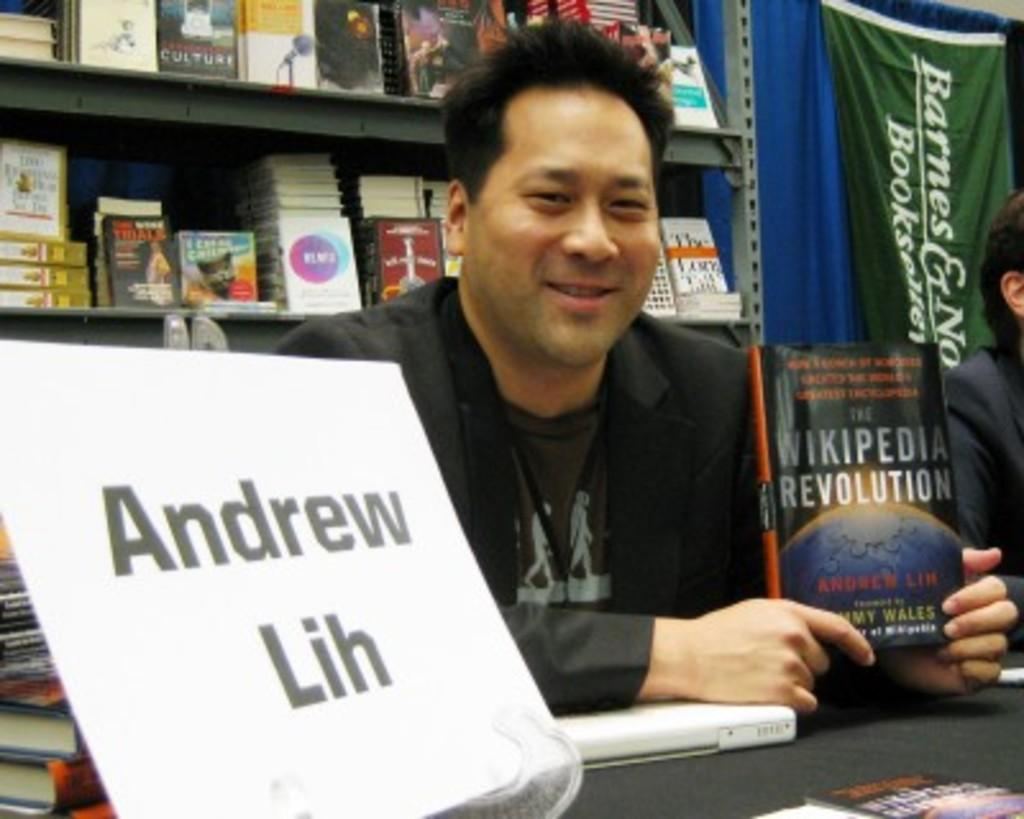<image>
Offer a succinct explanation of the picture presented. A man is sitting at a table with a sign that says Andrew Lih. 